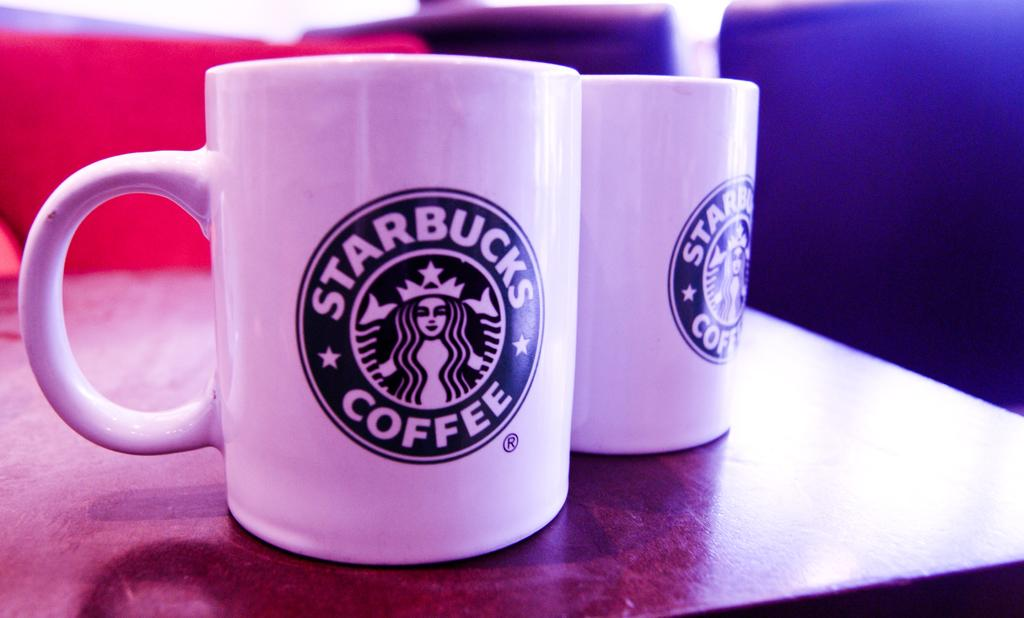<image>
Give a short and clear explanation of the subsequent image. A set of coffee mugs with the Starbucks Coffee logo on the front 